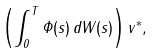Convert formula to latex. <formula><loc_0><loc_0><loc_500><loc_500>\left ( \int _ { 0 } ^ { T } \Phi ( s ) \, d W ( s ) \right ) v ^ { \ast } ,</formula> 